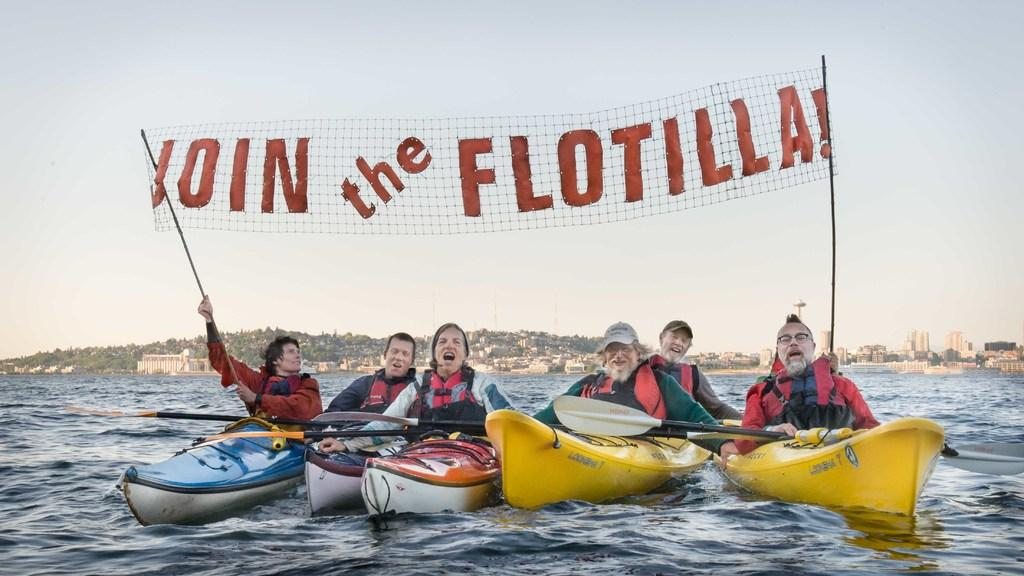Who can be seen in the image? There are people in the image. What are the people doing in the image? The people are riding boats in the image. Where are the boats located? The boats are in a river. Who is the owner of the river in the image? There is no indication of ownership of the river in the image. 